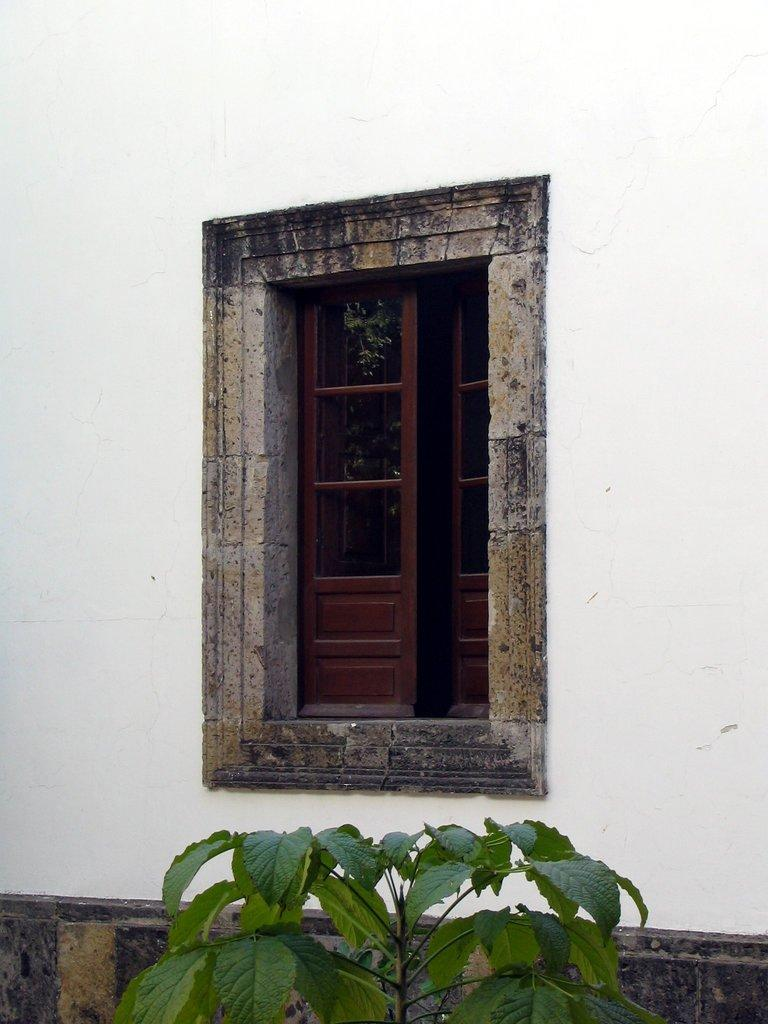What type of plant material is visible at the bottom of the image? There are leaves of a plant at the bottom of the image. What architectural feature is present in the middle of the image? There is a window in the middle of the image. What other feature is present in the middle of the image? There is a wall in the middle of the image. What type of skin condition can be seen on the wall in the image? There is no skin condition present in the image; it features a window and a wall. 